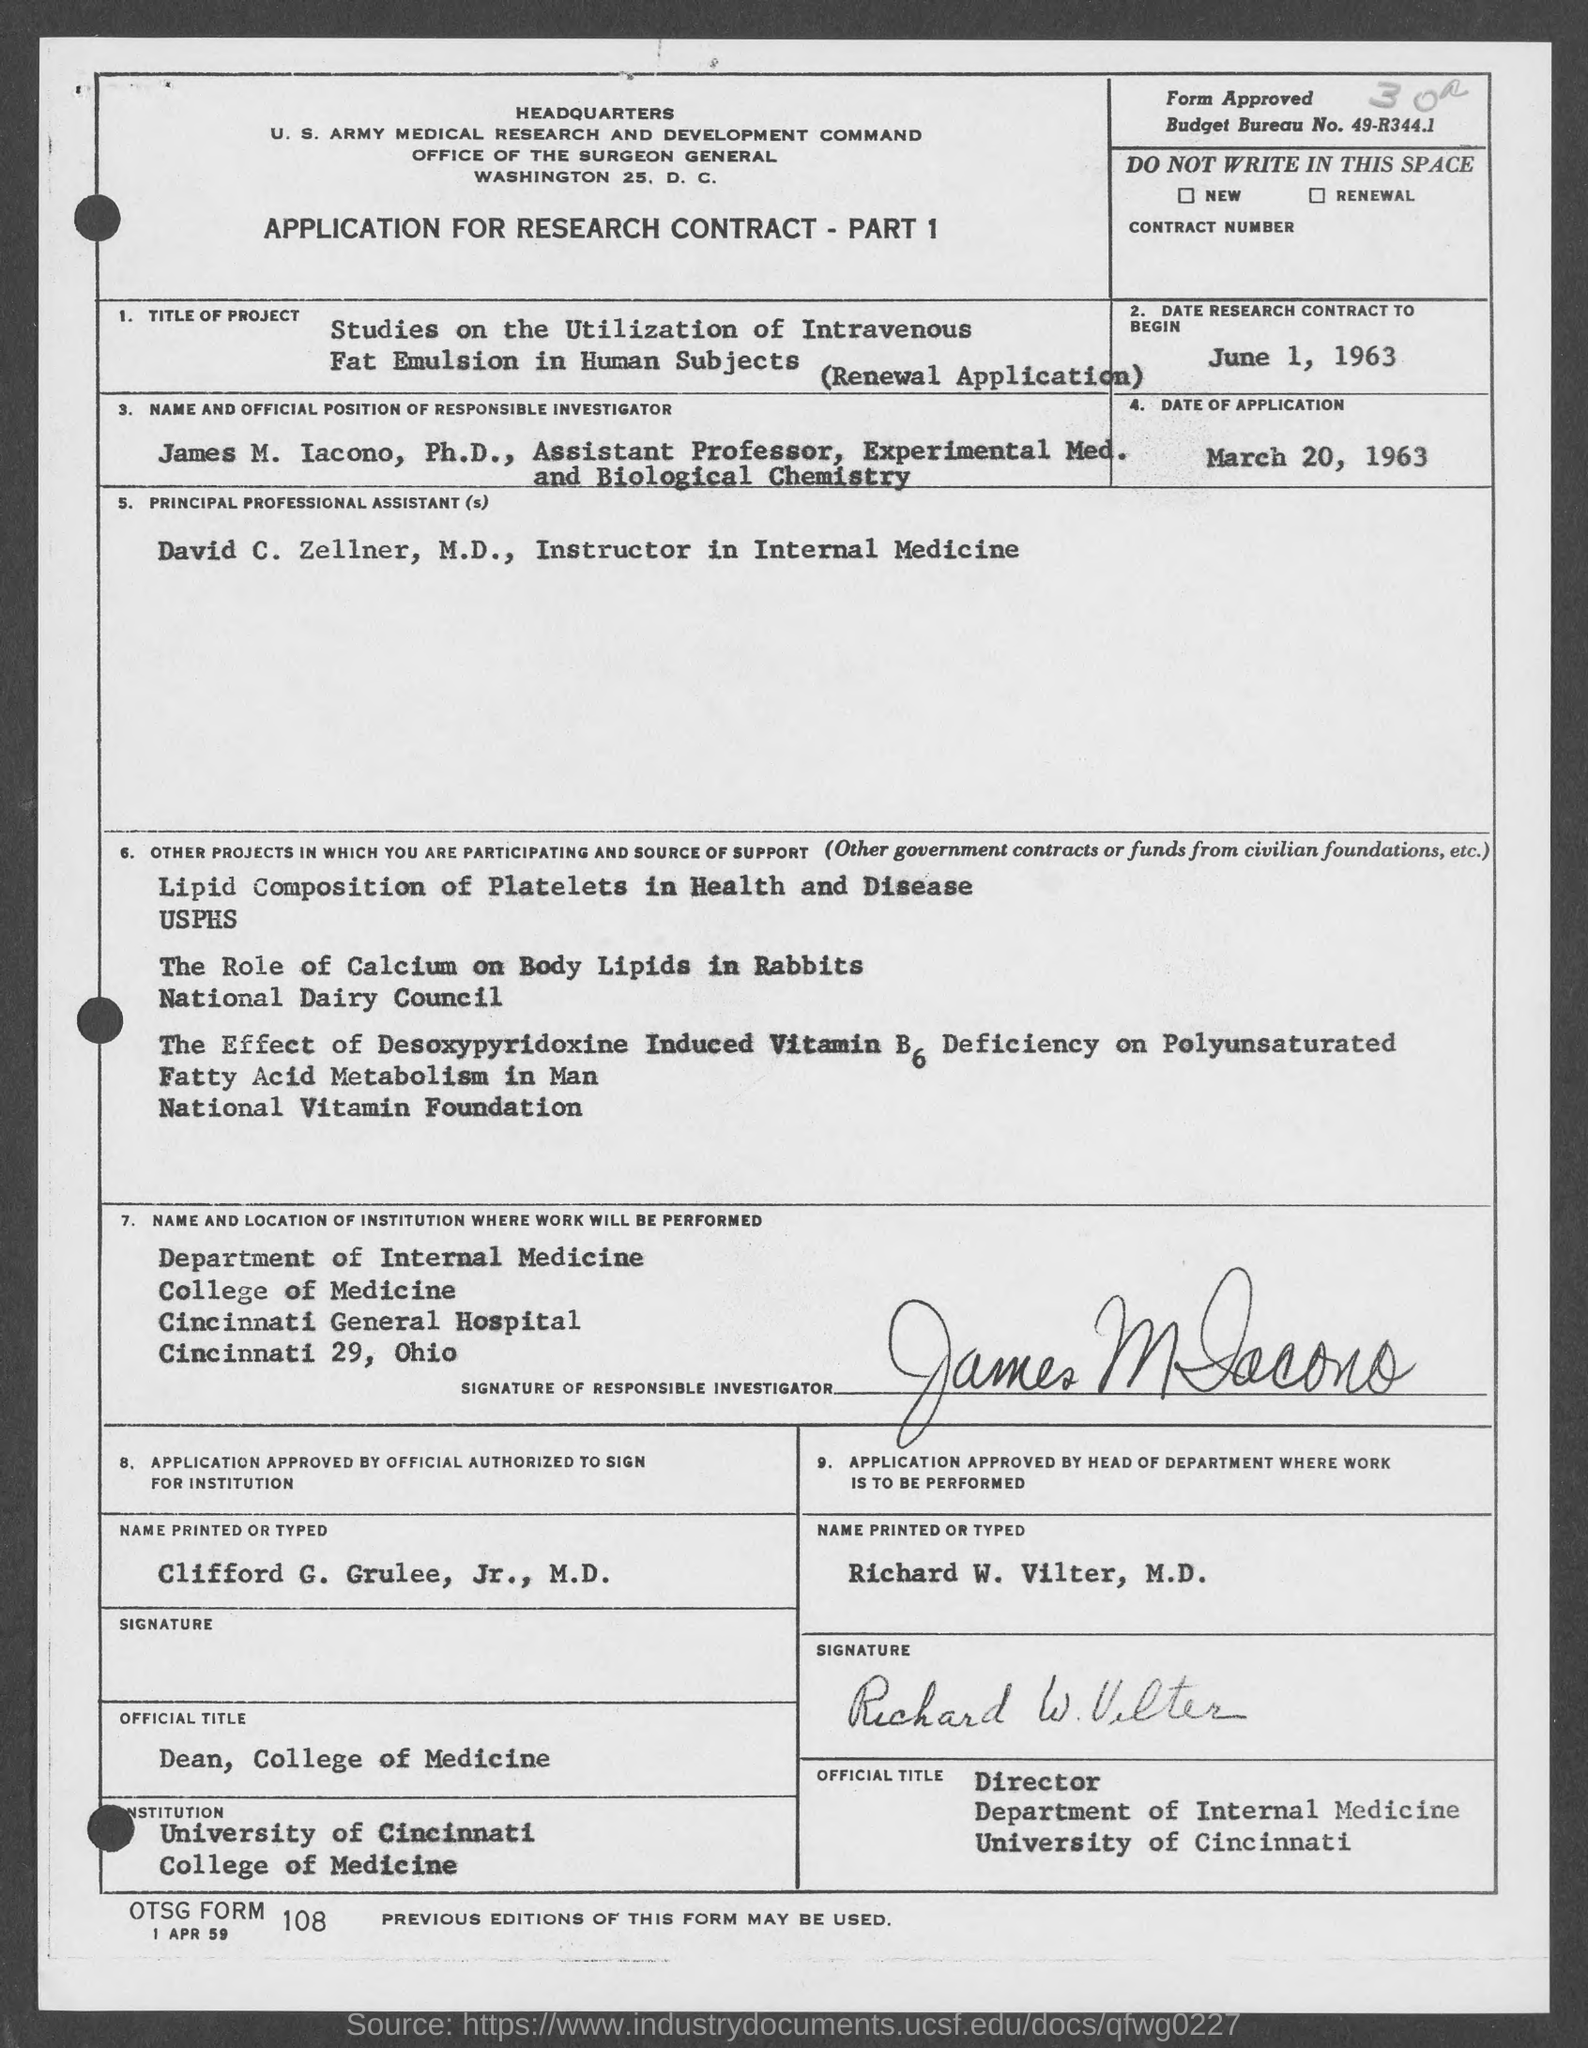Mention a couple of crucial points in this snapshot. The date for the research contract to begin, as specified in the given form, is June 1, 1963. The date of application mentioned in the given form is March 20, 1963. The budget bureau number mentioned in the provided form is 49-R344.1. 